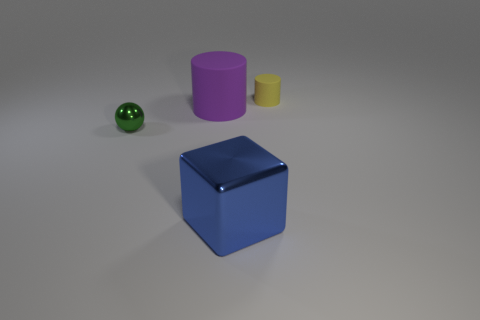There is a big thing in front of the large cylinder; is its shape the same as the tiny object that is to the right of the large blue thing?
Offer a terse response. No. Are there fewer small cylinders in front of the small ball than yellow objects that are in front of the yellow matte cylinder?
Provide a succinct answer. No. How many other objects are the same shape as the blue object?
Your answer should be very brief. 0. There is a thing that is made of the same material as the small yellow cylinder; what shape is it?
Offer a terse response. Cylinder. What is the color of the thing that is to the right of the large purple cylinder and behind the tiny metal ball?
Provide a short and direct response. Yellow. Do the big thing on the left side of the blue object and the block have the same material?
Give a very brief answer. No. Is the number of spheres on the right side of the blue metallic thing less than the number of large red rubber blocks?
Provide a succinct answer. No. Are there any large purple cylinders made of the same material as the small green sphere?
Keep it short and to the point. No. There is a ball; does it have the same size as the metal thing in front of the green shiny object?
Your answer should be very brief. No. Are there any small balls that have the same color as the big cylinder?
Your answer should be compact. No. 